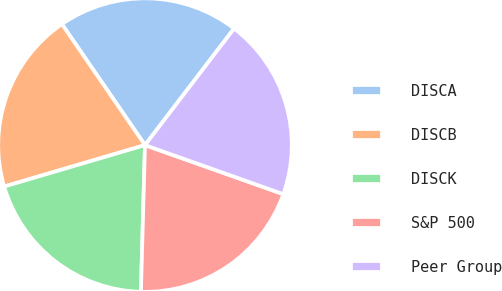Convert chart. <chart><loc_0><loc_0><loc_500><loc_500><pie_chart><fcel>DISCA<fcel>DISCB<fcel>DISCK<fcel>S&P 500<fcel>Peer Group<nl><fcel>19.96%<fcel>19.98%<fcel>20.0%<fcel>20.02%<fcel>20.04%<nl></chart> 